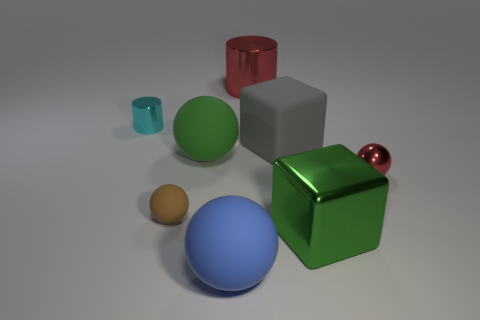Add 1 purple cylinders. How many objects exist? 9 Subtract all cylinders. How many objects are left? 6 Add 5 large green blocks. How many large green blocks exist? 6 Subtract 1 red balls. How many objects are left? 7 Subtract all metallic cylinders. Subtract all large metallic things. How many objects are left? 4 Add 6 big green things. How many big green things are left? 8 